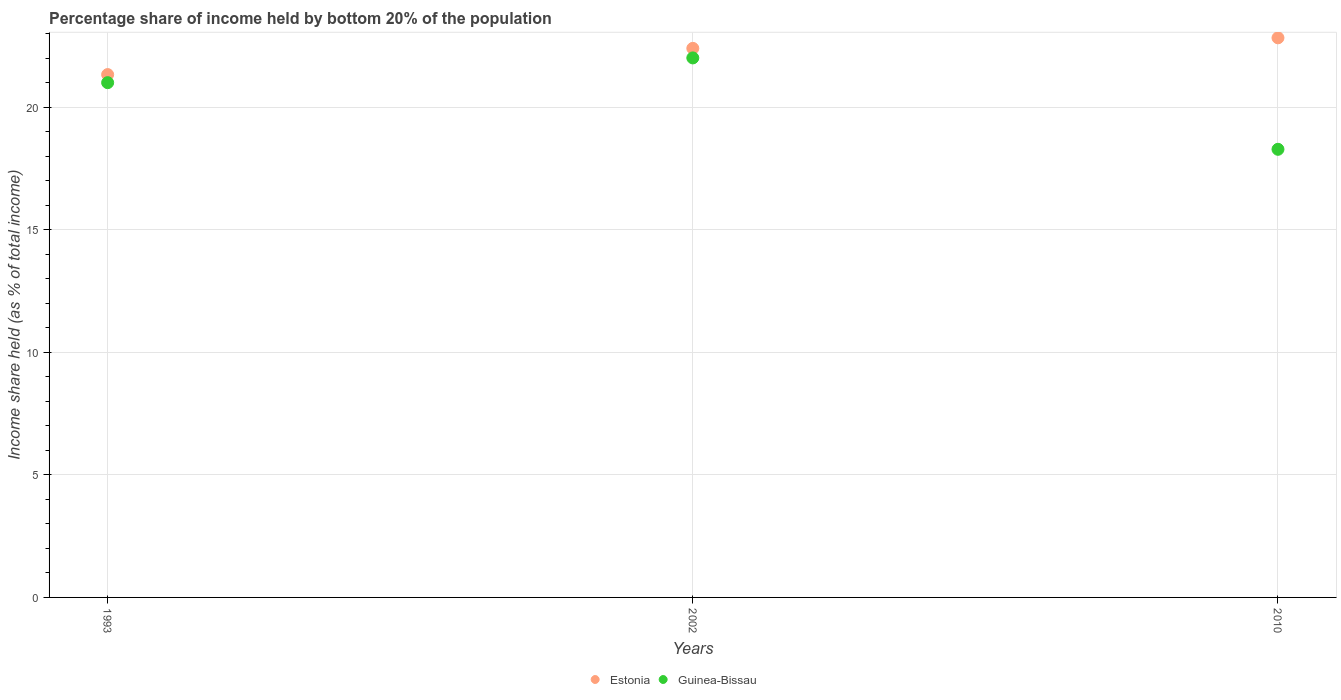Is the number of dotlines equal to the number of legend labels?
Keep it short and to the point. Yes. What is the share of income held by bottom 20% of the population in Estonia in 2002?
Ensure brevity in your answer.  22.41. Across all years, what is the maximum share of income held by bottom 20% of the population in Estonia?
Give a very brief answer. 22.84. Across all years, what is the minimum share of income held by bottom 20% of the population in Estonia?
Give a very brief answer. 21.34. In which year was the share of income held by bottom 20% of the population in Guinea-Bissau maximum?
Offer a terse response. 2002. In which year was the share of income held by bottom 20% of the population in Estonia minimum?
Make the answer very short. 1993. What is the total share of income held by bottom 20% of the population in Guinea-Bissau in the graph?
Make the answer very short. 61.32. What is the difference between the share of income held by bottom 20% of the population in Guinea-Bissau in 1993 and that in 2002?
Your answer should be compact. -1.01. What is the difference between the share of income held by bottom 20% of the population in Estonia in 2002 and the share of income held by bottom 20% of the population in Guinea-Bissau in 2010?
Offer a terse response. 4.12. What is the average share of income held by bottom 20% of the population in Estonia per year?
Make the answer very short. 22.2. In the year 2002, what is the difference between the share of income held by bottom 20% of the population in Estonia and share of income held by bottom 20% of the population in Guinea-Bissau?
Keep it short and to the point. 0.39. In how many years, is the share of income held by bottom 20% of the population in Guinea-Bissau greater than 2 %?
Provide a succinct answer. 3. What is the ratio of the share of income held by bottom 20% of the population in Estonia in 2002 to that in 2010?
Your answer should be compact. 0.98. What is the difference between the highest and the second highest share of income held by bottom 20% of the population in Estonia?
Give a very brief answer. 0.43. What is the difference between the highest and the lowest share of income held by bottom 20% of the population in Guinea-Bissau?
Provide a succinct answer. 3.73. Is the share of income held by bottom 20% of the population in Guinea-Bissau strictly greater than the share of income held by bottom 20% of the population in Estonia over the years?
Your answer should be compact. No. Is the share of income held by bottom 20% of the population in Guinea-Bissau strictly less than the share of income held by bottom 20% of the population in Estonia over the years?
Keep it short and to the point. Yes. How many years are there in the graph?
Your response must be concise. 3. Are the values on the major ticks of Y-axis written in scientific E-notation?
Provide a succinct answer. No. Does the graph contain any zero values?
Your response must be concise. No. What is the title of the graph?
Provide a short and direct response. Percentage share of income held by bottom 20% of the population. Does "Bhutan" appear as one of the legend labels in the graph?
Provide a succinct answer. No. What is the label or title of the Y-axis?
Offer a terse response. Income share held (as % of total income). What is the Income share held (as % of total income) in Estonia in 1993?
Provide a succinct answer. 21.34. What is the Income share held (as % of total income) in Guinea-Bissau in 1993?
Keep it short and to the point. 21.01. What is the Income share held (as % of total income) in Estonia in 2002?
Your response must be concise. 22.41. What is the Income share held (as % of total income) of Guinea-Bissau in 2002?
Your response must be concise. 22.02. What is the Income share held (as % of total income) of Estonia in 2010?
Give a very brief answer. 22.84. What is the Income share held (as % of total income) of Guinea-Bissau in 2010?
Provide a short and direct response. 18.29. Across all years, what is the maximum Income share held (as % of total income) of Estonia?
Provide a succinct answer. 22.84. Across all years, what is the maximum Income share held (as % of total income) of Guinea-Bissau?
Your answer should be very brief. 22.02. Across all years, what is the minimum Income share held (as % of total income) of Estonia?
Give a very brief answer. 21.34. Across all years, what is the minimum Income share held (as % of total income) of Guinea-Bissau?
Offer a very short reply. 18.29. What is the total Income share held (as % of total income) in Estonia in the graph?
Your answer should be very brief. 66.59. What is the total Income share held (as % of total income) in Guinea-Bissau in the graph?
Ensure brevity in your answer.  61.32. What is the difference between the Income share held (as % of total income) of Estonia in 1993 and that in 2002?
Your response must be concise. -1.07. What is the difference between the Income share held (as % of total income) in Guinea-Bissau in 1993 and that in 2002?
Give a very brief answer. -1.01. What is the difference between the Income share held (as % of total income) of Estonia in 1993 and that in 2010?
Your response must be concise. -1.5. What is the difference between the Income share held (as % of total income) of Guinea-Bissau in 1993 and that in 2010?
Offer a very short reply. 2.72. What is the difference between the Income share held (as % of total income) of Estonia in 2002 and that in 2010?
Keep it short and to the point. -0.43. What is the difference between the Income share held (as % of total income) of Guinea-Bissau in 2002 and that in 2010?
Your answer should be very brief. 3.73. What is the difference between the Income share held (as % of total income) in Estonia in 1993 and the Income share held (as % of total income) in Guinea-Bissau in 2002?
Provide a succinct answer. -0.68. What is the difference between the Income share held (as % of total income) of Estonia in 1993 and the Income share held (as % of total income) of Guinea-Bissau in 2010?
Your answer should be compact. 3.05. What is the difference between the Income share held (as % of total income) of Estonia in 2002 and the Income share held (as % of total income) of Guinea-Bissau in 2010?
Keep it short and to the point. 4.12. What is the average Income share held (as % of total income) of Estonia per year?
Give a very brief answer. 22.2. What is the average Income share held (as % of total income) of Guinea-Bissau per year?
Offer a terse response. 20.44. In the year 1993, what is the difference between the Income share held (as % of total income) of Estonia and Income share held (as % of total income) of Guinea-Bissau?
Ensure brevity in your answer.  0.33. In the year 2002, what is the difference between the Income share held (as % of total income) of Estonia and Income share held (as % of total income) of Guinea-Bissau?
Your answer should be compact. 0.39. In the year 2010, what is the difference between the Income share held (as % of total income) of Estonia and Income share held (as % of total income) of Guinea-Bissau?
Provide a succinct answer. 4.55. What is the ratio of the Income share held (as % of total income) in Estonia in 1993 to that in 2002?
Your response must be concise. 0.95. What is the ratio of the Income share held (as % of total income) of Guinea-Bissau in 1993 to that in 2002?
Keep it short and to the point. 0.95. What is the ratio of the Income share held (as % of total income) of Estonia in 1993 to that in 2010?
Offer a terse response. 0.93. What is the ratio of the Income share held (as % of total income) in Guinea-Bissau in 1993 to that in 2010?
Your answer should be compact. 1.15. What is the ratio of the Income share held (as % of total income) in Estonia in 2002 to that in 2010?
Ensure brevity in your answer.  0.98. What is the ratio of the Income share held (as % of total income) in Guinea-Bissau in 2002 to that in 2010?
Keep it short and to the point. 1.2. What is the difference between the highest and the second highest Income share held (as % of total income) in Estonia?
Your response must be concise. 0.43. What is the difference between the highest and the lowest Income share held (as % of total income) in Estonia?
Your answer should be compact. 1.5. What is the difference between the highest and the lowest Income share held (as % of total income) of Guinea-Bissau?
Your response must be concise. 3.73. 